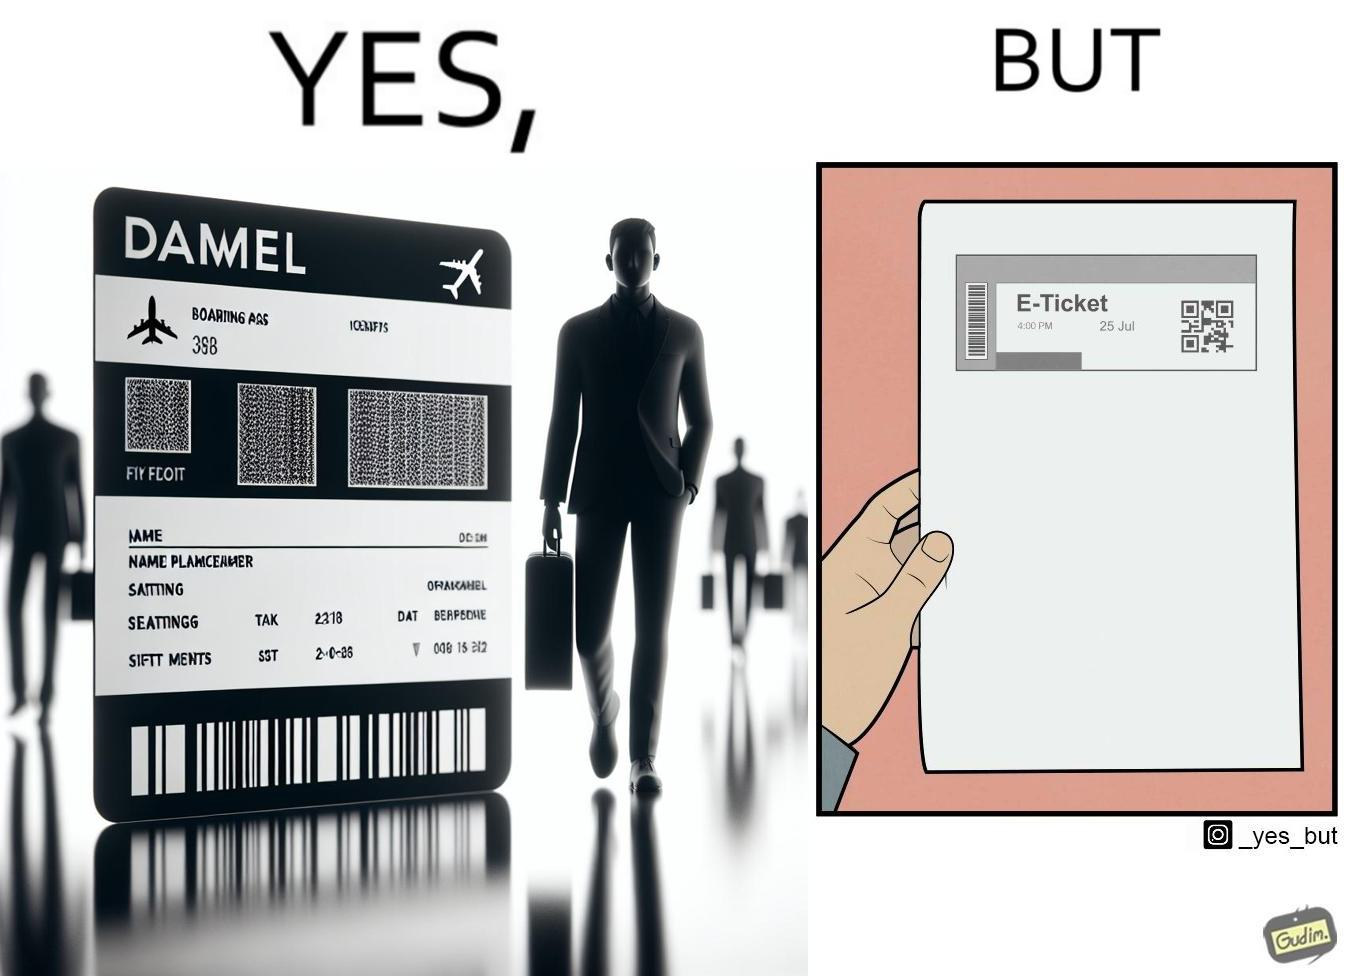What is the satirical meaning behind this image? The images are ironic since even though e-tickets are provided to save resources like paper, people choose to print out e-tickets on large sheets of paper which leads to more wastage 